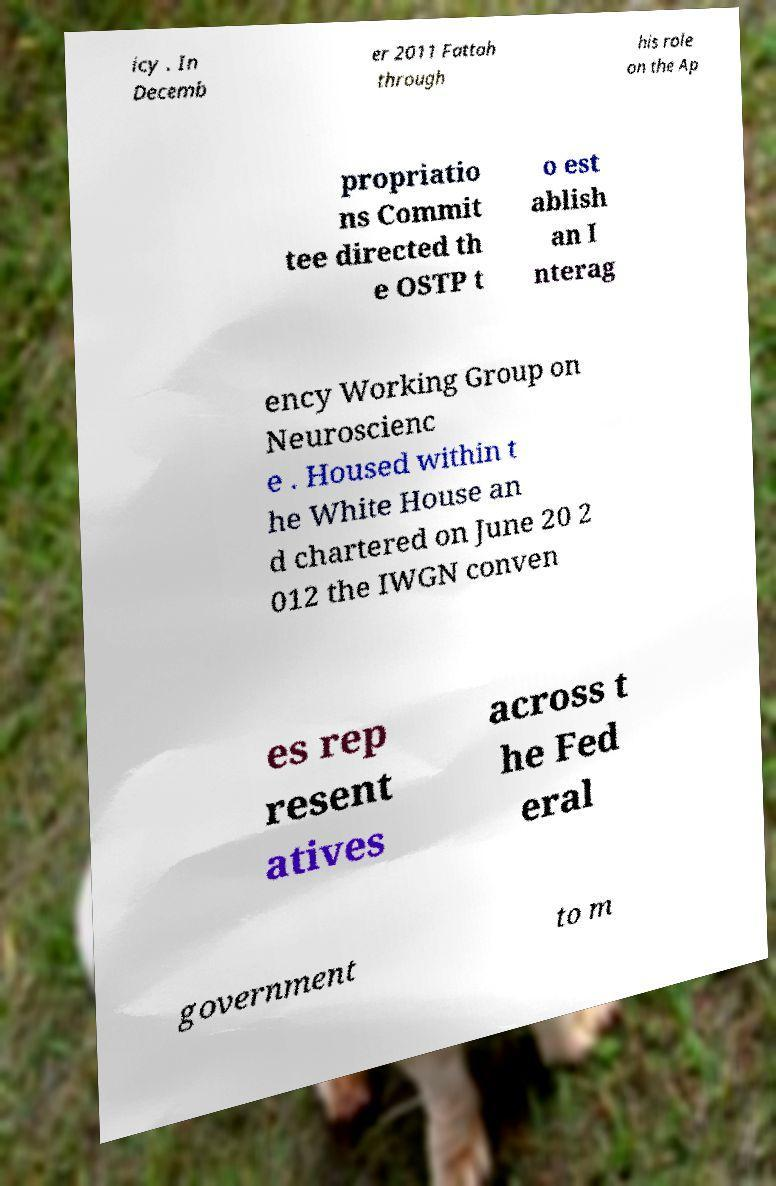For documentation purposes, I need the text within this image transcribed. Could you provide that? icy . In Decemb er 2011 Fattah through his role on the Ap propriatio ns Commit tee directed th e OSTP t o est ablish an I nterag ency Working Group on Neuroscienc e . Housed within t he White House an d chartered on June 20 2 012 the IWGN conven es rep resent atives across t he Fed eral government to m 